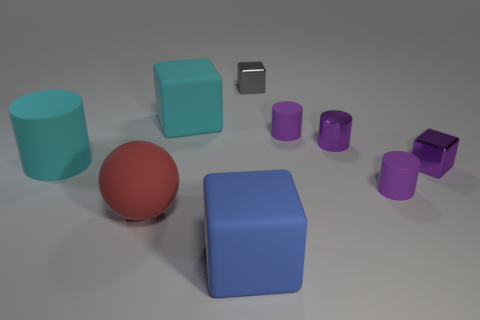How many purple cylinders must be subtracted to get 1 purple cylinders? 2 Subtract all green spheres. How many purple cylinders are left? 3 Subtract all blocks. How many objects are left? 5 Add 8 big red matte cylinders. How many big red matte cylinders exist? 8 Subtract 1 blue cubes. How many objects are left? 8 Subtract all cyan cubes. Subtract all tiny purple metal things. How many objects are left? 6 Add 1 cyan rubber blocks. How many cyan rubber blocks are left? 2 